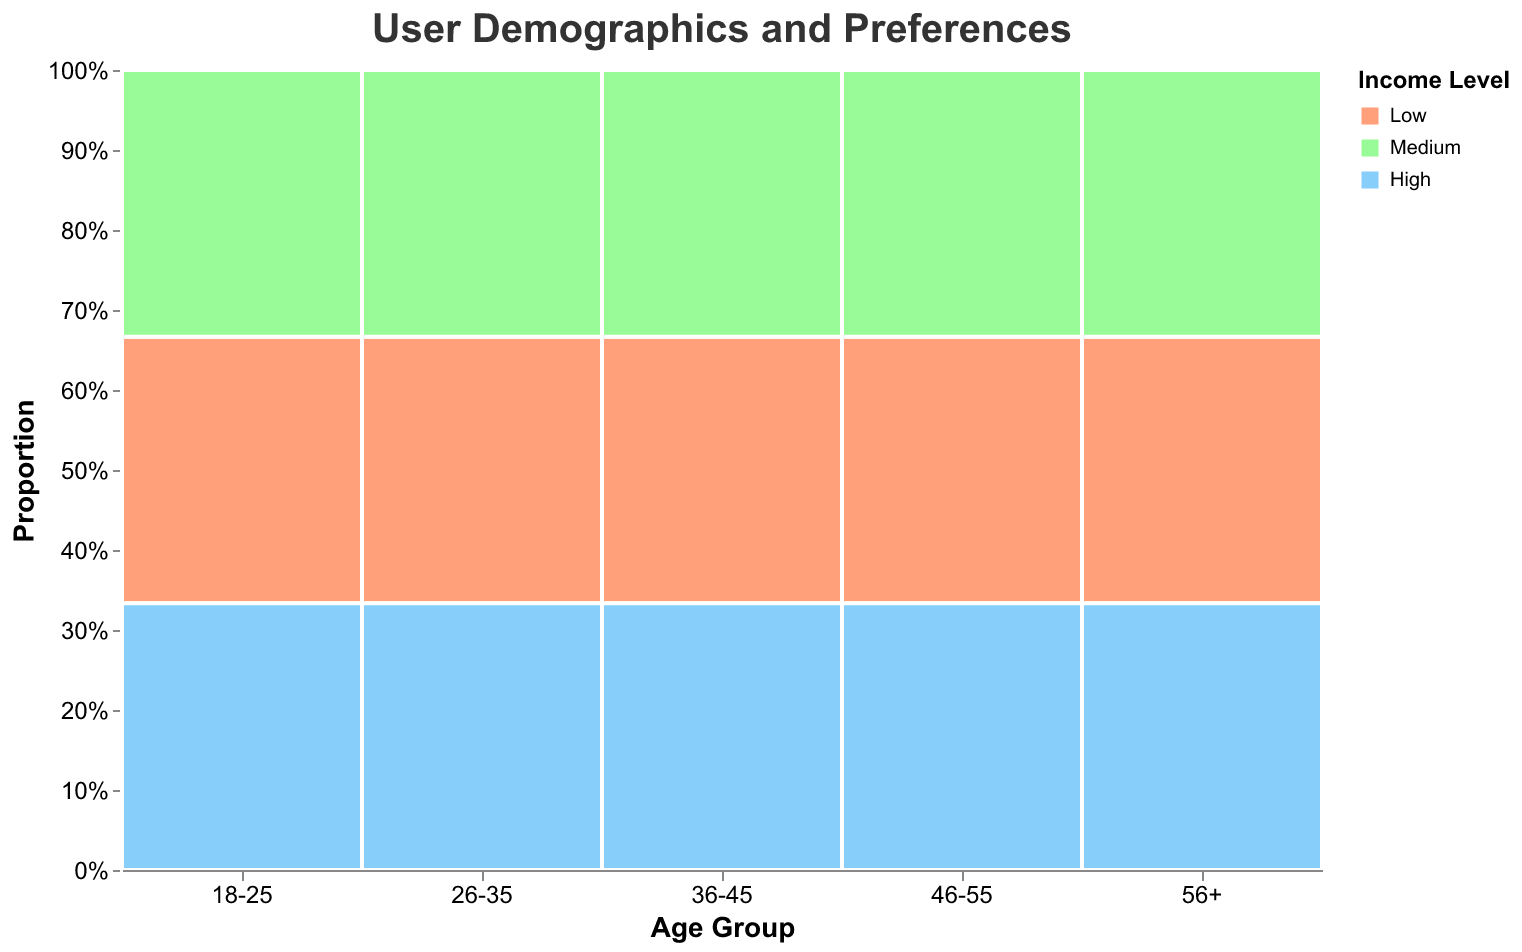What's the title of the figure? The title of the figure is written at the top center and typically provides an overview of what the plot represents.
Answer: User Demographics and Preferences What's the proportion of users in the "18-25" age group with a "High" income level? Find the "18-25" age group on the x-axis, then look at the section of the bar colored to represent "High" income level. The height of this section relative to the total bar height gives the proportion.
Answer: 33.3% Which age group has the largest proportion of users with "Medium" income level? Compare the sections colored for "Medium" income level across all age groups. The tallest section represents the largest proportion.
Answer: 26-35 Which digital wallet is preferred by users aged "36-45" with a "High" income level? Look for the 36-45 age group and identify the preference column that corresponds to the "High" income level. Check the tooltip for validation.
Answer: Samsung Pay How do the digital wallet preferences vary between "Low" income levels across different age groups? Analyze the sections colored for "Low" income level in each age group's bar and observe the differing digital wallets.
Answer: Varies significantly: "Cash App," "Google Pay," "Zelle," "Skrill," "Western Union" What is the total proportion of "High" income levels across all age groups? Calculate the sum of the proportions of the "High" income level across all age group sections.
Answer: 33.3% Which cryptocurrency exchange is preferred by users aged "46-55" with a "Medium" income level? Locate the 46-55 age group bar, identify the preference section for "Medium" income, and read the tooltip.
Answer: Bittrex Compare the digital wallet preference for users aged "56+" with a "Medium" income level to those aged "26-35" with the same income level. Identify the digital wallet preferences for the respective age group and income level, and provide the wallet names for comparison.
Answer: Alipay vs. PayPal 